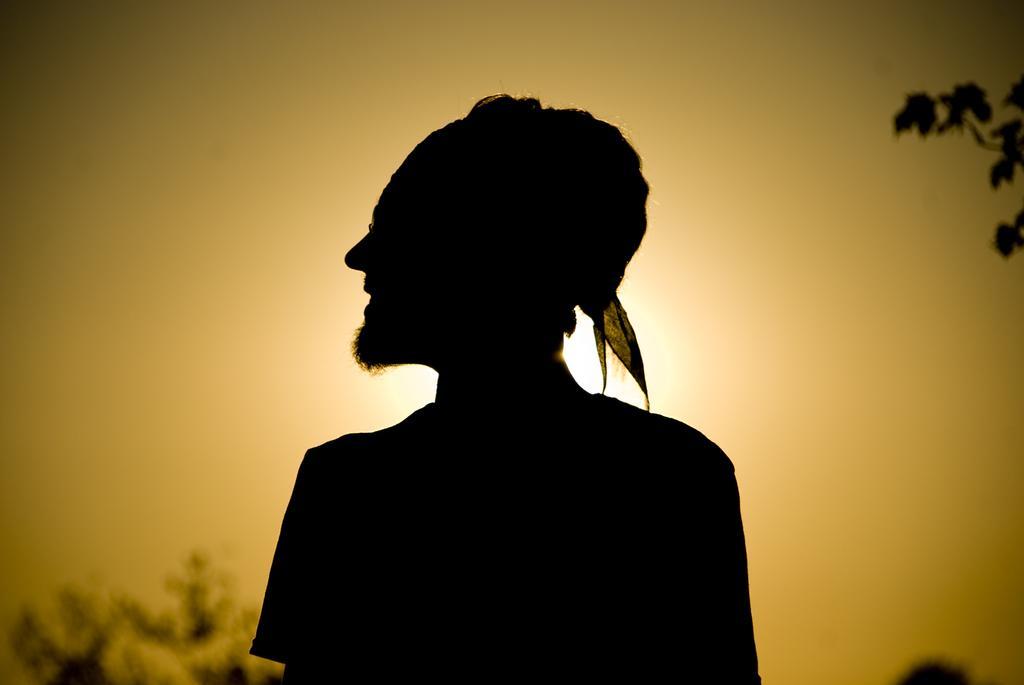Could you give a brief overview of what you see in this image? In the foreground of the picture there is a person standing. On the right there is a stem of a tree. On the left there is a tree. Sky is sunny. 